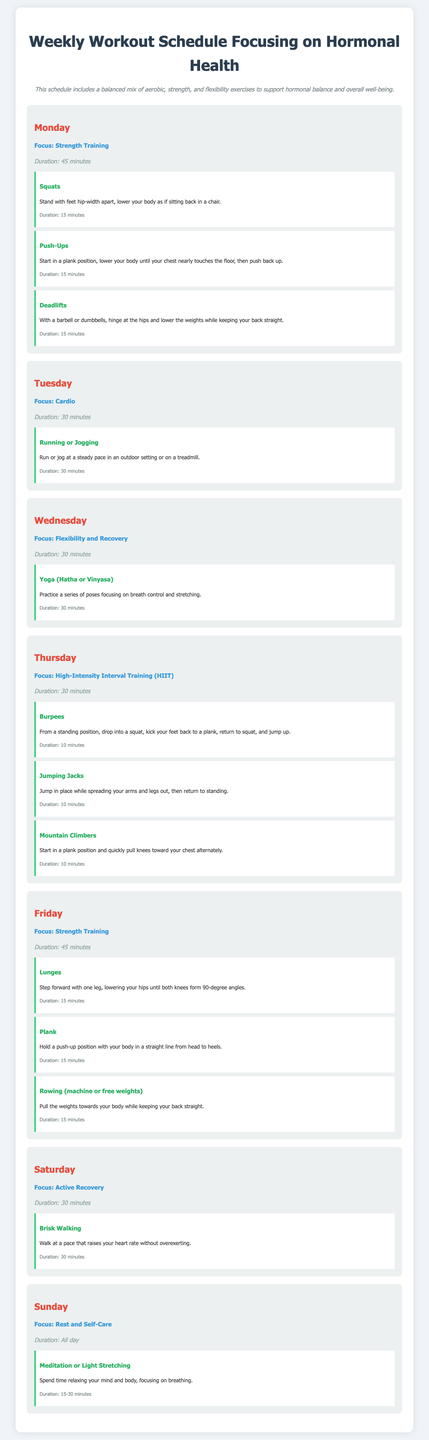What is the focus for Monday? The focus for Monday is stated as "Strength Training."
Answer: Strength Training How long is the workout duration on Tuesday? The document specifies that Tuesday's workout duration is "30 minutes."
Answer: 30 minutes What exercise follows squats on Monday? The exercises listed for Monday show that "Push-Ups" follow "Squats."
Answer: Push-Ups What type of training is highlighted on Thursday? The document indicates that Thursday emphasizes "High-Intensity Interval Training (HIIT)."
Answer: High-Intensity Interval Training (HIIT) How many minutes are dedicated to yoga on Wednesday? The duration for yoga on Wednesday is provided as "30 minutes."
Answer: 30 minutes What is the focus for Sunday? The document announces Sunday’s focus as "Rest and Self-Care."
Answer: Rest and Self-Care What activity is recommended for Saturday's active recovery? The Saturday workout suggests "Brisk Walking" as the active recovery activity.
Answer: Brisk Walking How many exercises are listed for Thursday? Thursday includes three exercises: Burpees, Jumping Jacks, and Mountain Climbers.
Answer: Three What is the duration of the strength training session on Friday? The strength training session on Friday has a specified duration of "45 minutes."
Answer: 45 minutes 